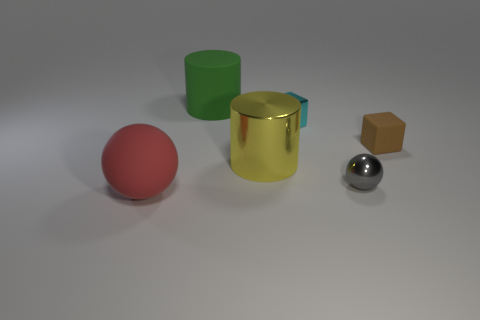What is the time of day suggested by the lighting in this scene? The lighting in this scene suggests an indoor setting with artificial lighting rather than a specific time of day. The shadows are soft and diffuse, typical of a space with general ambient lighting, such as a room lit by overhead lights. 